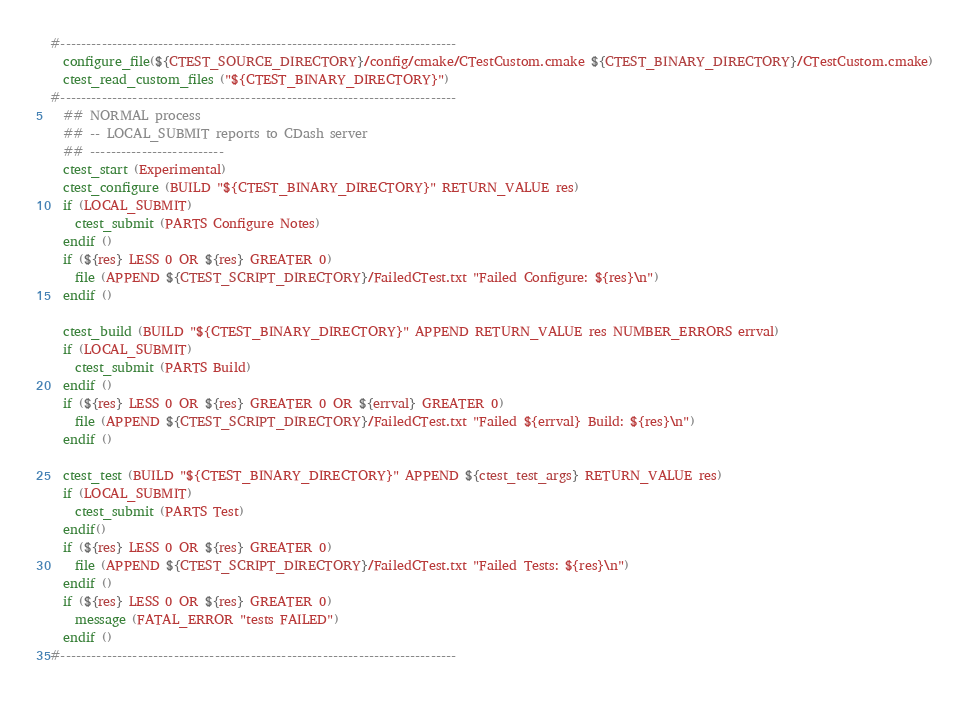Convert code to text. <code><loc_0><loc_0><loc_500><loc_500><_CMake_>
#-----------------------------------------------------------------------------
  configure_file(${CTEST_SOURCE_DIRECTORY}/config/cmake/CTestCustom.cmake ${CTEST_BINARY_DIRECTORY}/CTestCustom.cmake)
  ctest_read_custom_files ("${CTEST_BINARY_DIRECTORY}")
#-----------------------------------------------------------------------------
  ## NORMAL process
  ## -- LOCAL_SUBMIT reports to CDash server
  ## --------------------------
  ctest_start (Experimental)
  ctest_configure (BUILD "${CTEST_BINARY_DIRECTORY}" RETURN_VALUE res)
  if (LOCAL_SUBMIT)
    ctest_submit (PARTS Configure Notes)
  endif ()
  if (${res} LESS 0 OR ${res} GREATER 0)
    file (APPEND ${CTEST_SCRIPT_DIRECTORY}/FailedCTest.txt "Failed Configure: ${res}\n")
  endif ()

  ctest_build (BUILD "${CTEST_BINARY_DIRECTORY}" APPEND RETURN_VALUE res NUMBER_ERRORS errval)
  if (LOCAL_SUBMIT)
    ctest_submit (PARTS Build)
  endif ()
  if (${res} LESS 0 OR ${res} GREATER 0 OR ${errval} GREATER 0)
    file (APPEND ${CTEST_SCRIPT_DIRECTORY}/FailedCTest.txt "Failed ${errval} Build: ${res}\n")
  endif ()

  ctest_test (BUILD "${CTEST_BINARY_DIRECTORY}" APPEND ${ctest_test_args} RETURN_VALUE res)
  if (LOCAL_SUBMIT)
    ctest_submit (PARTS Test)
  endif()
  if (${res} LESS 0 OR ${res} GREATER 0)
    file (APPEND ${CTEST_SCRIPT_DIRECTORY}/FailedCTest.txt "Failed Tests: ${res}\n")
  endif ()
  if (${res} LESS 0 OR ${res} GREATER 0)
    message (FATAL_ERROR "tests FAILED")
  endif ()
#-----------------------------------------------------------------------------
</code> 